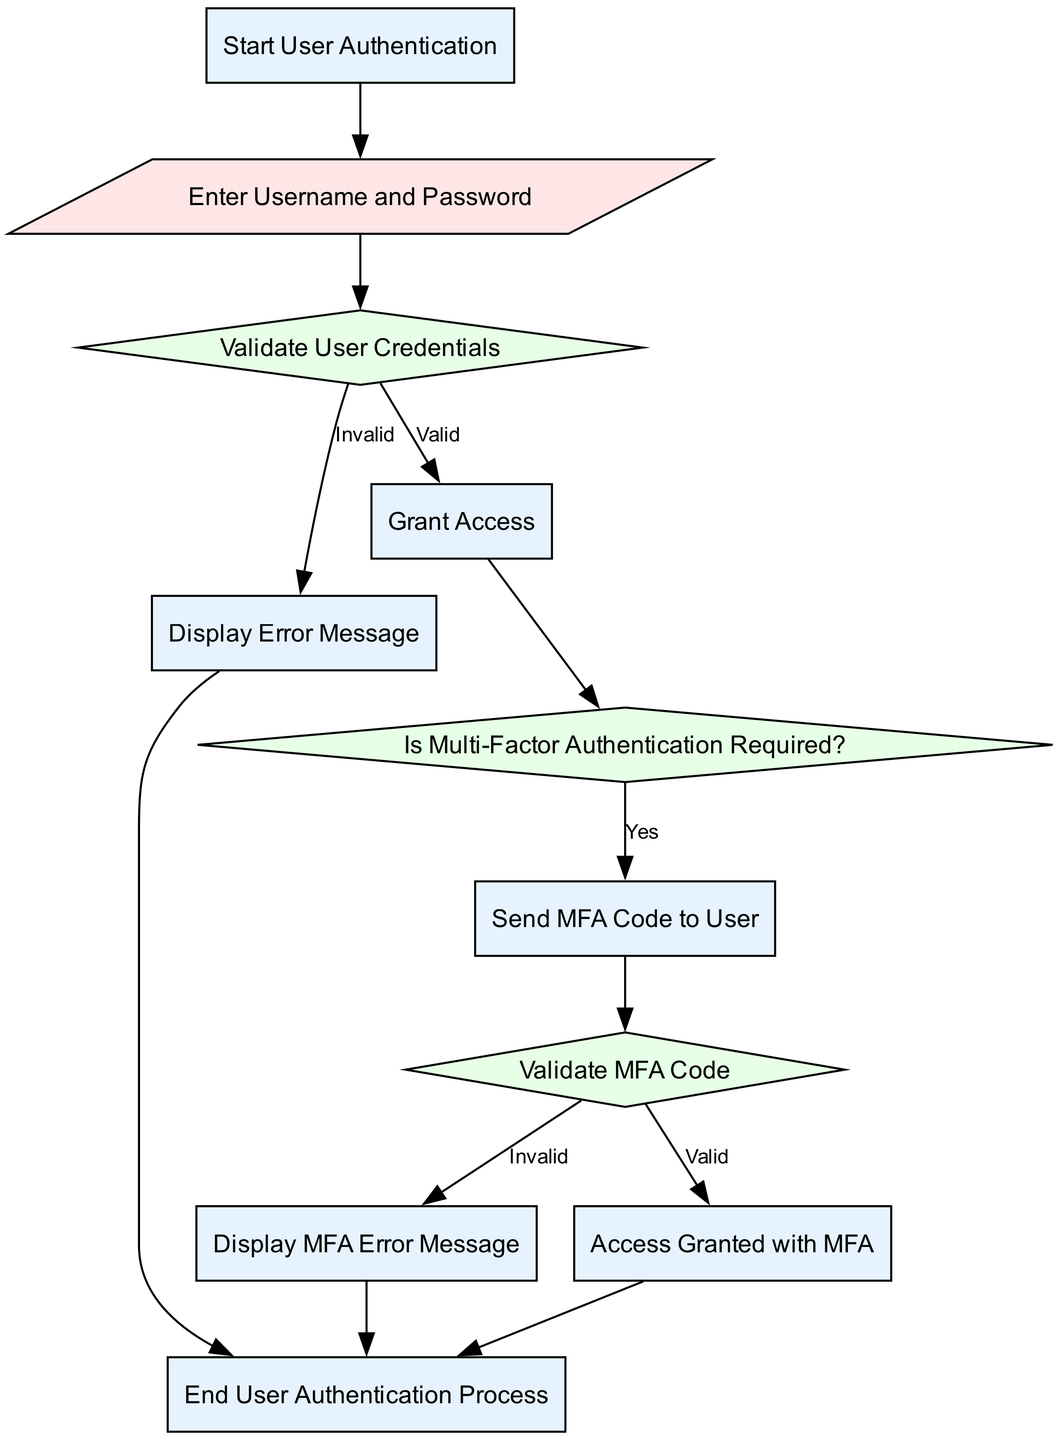What is the first step in the user authentication process? The first step, represented by the "Start" node, is to initiate the user authentication process.
Answer: Start User Authentication How many decision nodes are present in the flow chart? There are three decision nodes: "Validate User Credentials," "Is Multi-Factor Authentication Required?" and "Validate MFA Code."
Answer: 3 What happens if the credentials are invalid? If the credentials are invalid, the process flows to the "Display Error Message" node, and then ends the user authentication process.
Answer: Display Error Message If multi-factor authentication is required, what is the next step after sending the MFA code? After sending the MFA code, the next step is to validate the MFA code in the "Validate MFA" decision node.
Answer: Validate MFA What is the outcome if the MFA code is valid? If the MFA code is valid, the user is granted access through the "Access Granted with MFA" process before ending the authentication.
Answer: Access Granted with MFA How does the flow proceed once the user credentials are validated? Once user credentials are validated, the flow goes to the question of whether multi-factor authentication is required, represented by the "Is Multi-Factor Authentication Required?" decision node.
Answer: Multi-Factor Authentication Required? 